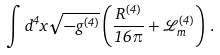<formula> <loc_0><loc_0><loc_500><loc_500>\int d ^ { 4 } x \sqrt { - g ^ { ( 4 ) } } \left ( \frac { R ^ { ( 4 ) } } { 1 6 \pi } + \mathcal { L } ^ { ( 4 ) } _ { m } \right ) \, .</formula> 